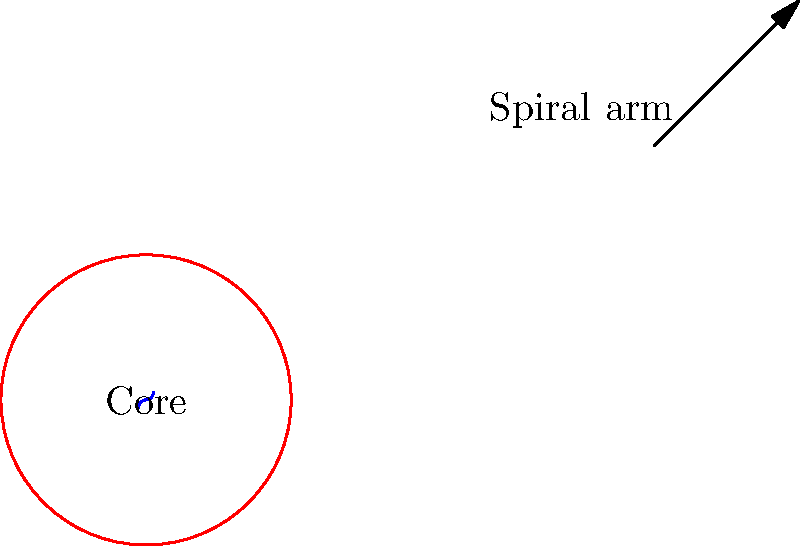In the simple spiral galaxy illustration, what does the red circle in the center represent, and how does it relate to the overall structure of the galaxy? To understand the structure of a spiral galaxy, let's break it down step-by-step:

1. The illustration shows a simplified view of a spiral galaxy from above.

2. The red circle in the center represents the core or bulge of the galaxy. This is the densest and oldest part of the galaxy, containing mostly older stars and less gas and dust.

3. The blue spiral arms extending from the core are where most of the galaxy's star formation occurs. These arms contain younger stars, as well as large amounts of gas and dust.

4. The core (red circle) is crucial to the galaxy's structure because:
   a) It contains the supermassive black hole at the galaxy's center, which influences the galaxy's evolution.
   b) Its gravitational pull helps maintain the spiral structure.
   c) It contains the oldest stellar population, providing insights into the galaxy's history.

5. The relationship between the core and spiral arms is dynamic:
   a) Material from the spiral arms can be drawn into the core over time.
   b) The core's gravity helps shape and maintain the spiral arm structure.
   c) The rotation of the core and inner regions of the galaxy influences the rotation of the outer spiral arms.

Understanding this structure is important for IT technicians working with astronomical data or systems, as it provides context for the types of data being processed and stored in astronomical databases or content management systems.
Answer: The red circle represents the galaxy's core, which is crucial for maintaining the galaxy's structure and contains the oldest stellar population. 